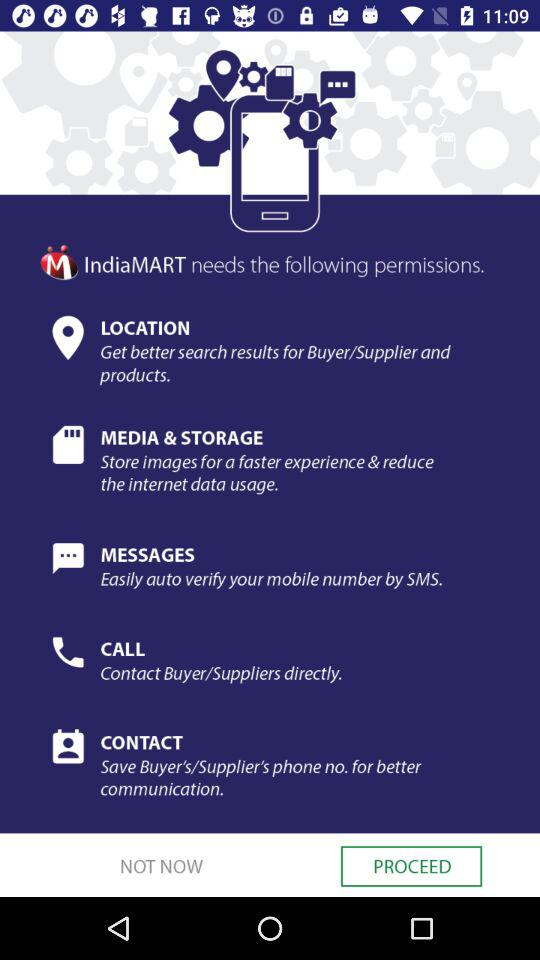How many of the permissions are related to contact management?
Answer the question using a single word or phrase. 2 